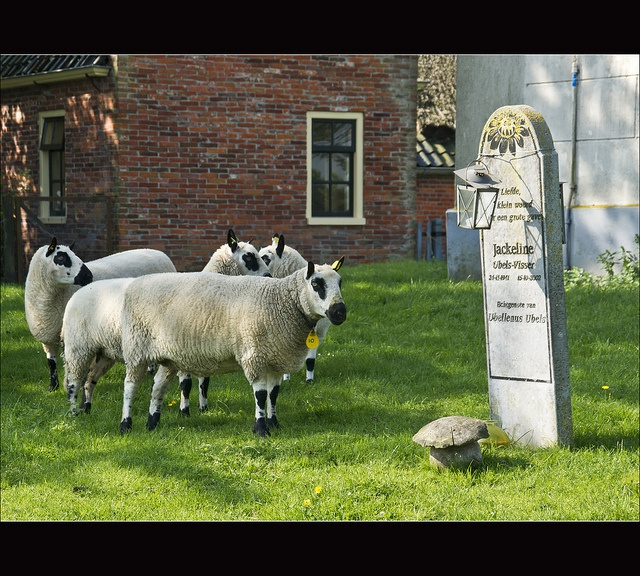Describe the objects in this image and their specific colors. I can see sheep in black, darkgray, and gray tones, sheep in black, lightgray, darkgray, and gray tones, sheep in black, darkgray, gray, and lightgray tones, and sheep in black, darkgray, gray, and lightgray tones in this image. 